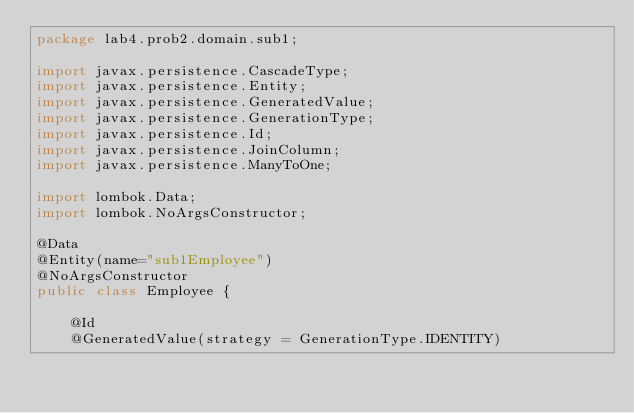Convert code to text. <code><loc_0><loc_0><loc_500><loc_500><_Java_>package lab4.prob2.domain.sub1;

import javax.persistence.CascadeType;
import javax.persistence.Entity;
import javax.persistence.GeneratedValue;
import javax.persistence.GenerationType;
import javax.persistence.Id;
import javax.persistence.JoinColumn;
import javax.persistence.ManyToOne;

import lombok.Data;	
import lombok.NoArgsConstructor;

@Data
@Entity(name="sub1Employee")
@NoArgsConstructor
public class Employee {
	
	@Id
	@GeneratedValue(strategy = GenerationType.IDENTITY)</code> 